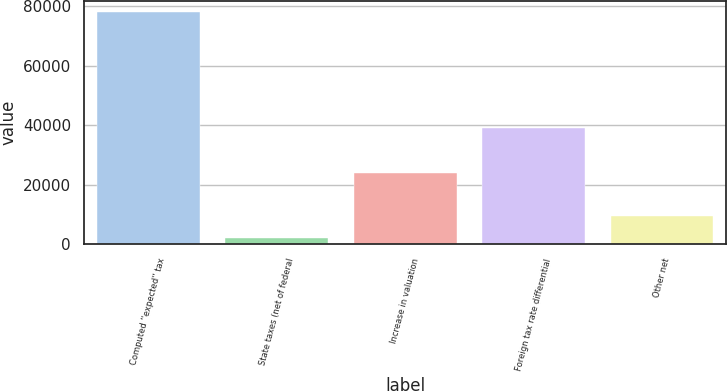Convert chart. <chart><loc_0><loc_0><loc_500><loc_500><bar_chart><fcel>Computed ''expected'' tax<fcel>State taxes (net of federal<fcel>Increase in valuation<fcel>Foreign tax rate differential<fcel>Other net<nl><fcel>78058<fcel>1844<fcel>23962<fcel>38917<fcel>9465.4<nl></chart> 